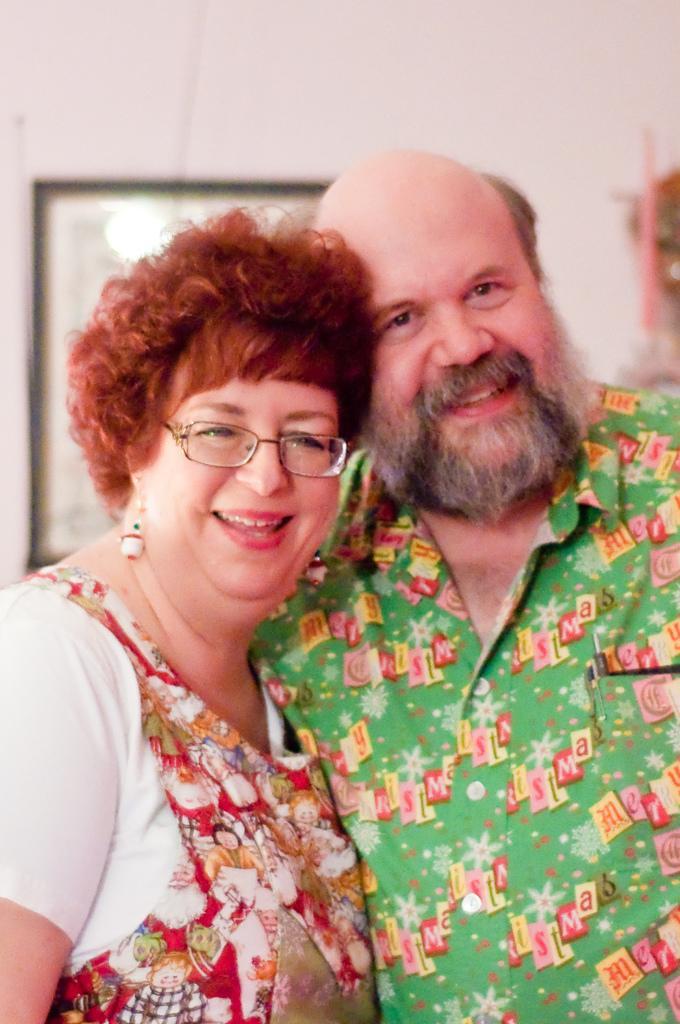Describe this image in one or two sentences. This picture shows a man and a woman standing with a smile on their faces and we see women wore spectacles on his face and we see a photo frame on the wall. 